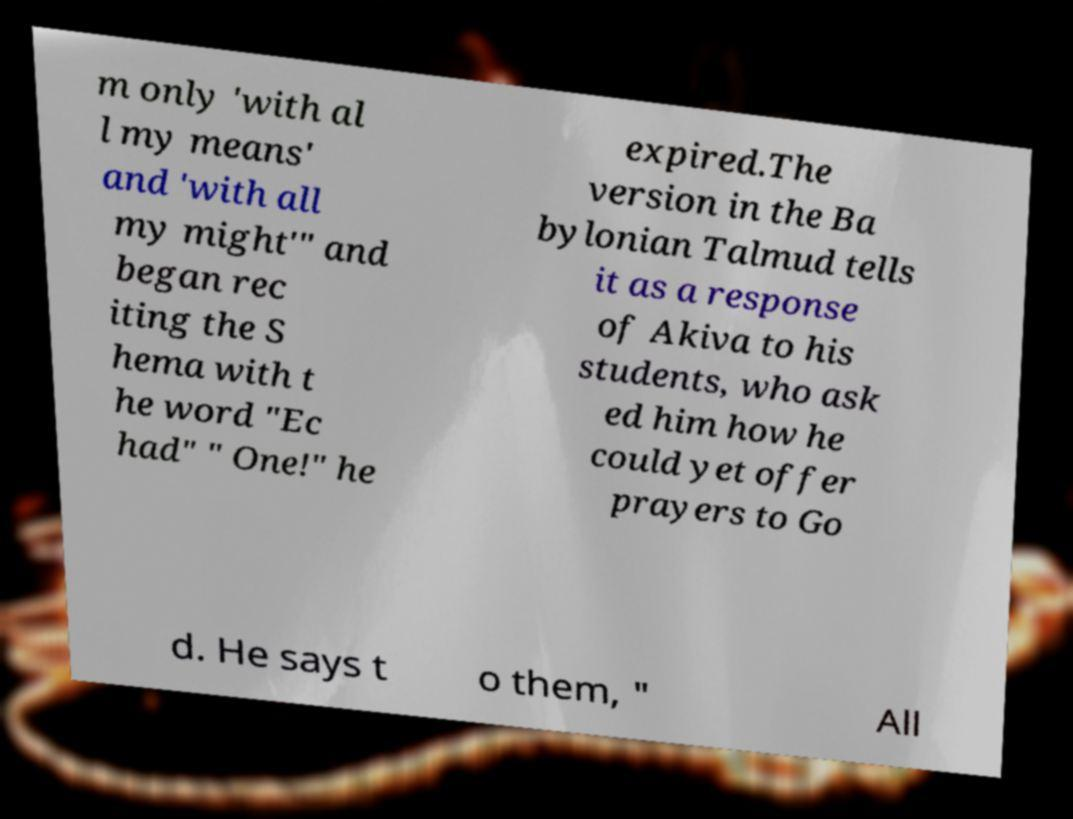What messages or text are displayed in this image? I need them in a readable, typed format. m only 'with al l my means' and 'with all my might'" and began rec iting the S hema with t he word "Ec had" " One!" he expired.The version in the Ba bylonian Talmud tells it as a response of Akiva to his students, who ask ed him how he could yet offer prayers to Go d. He says t o them, " All 